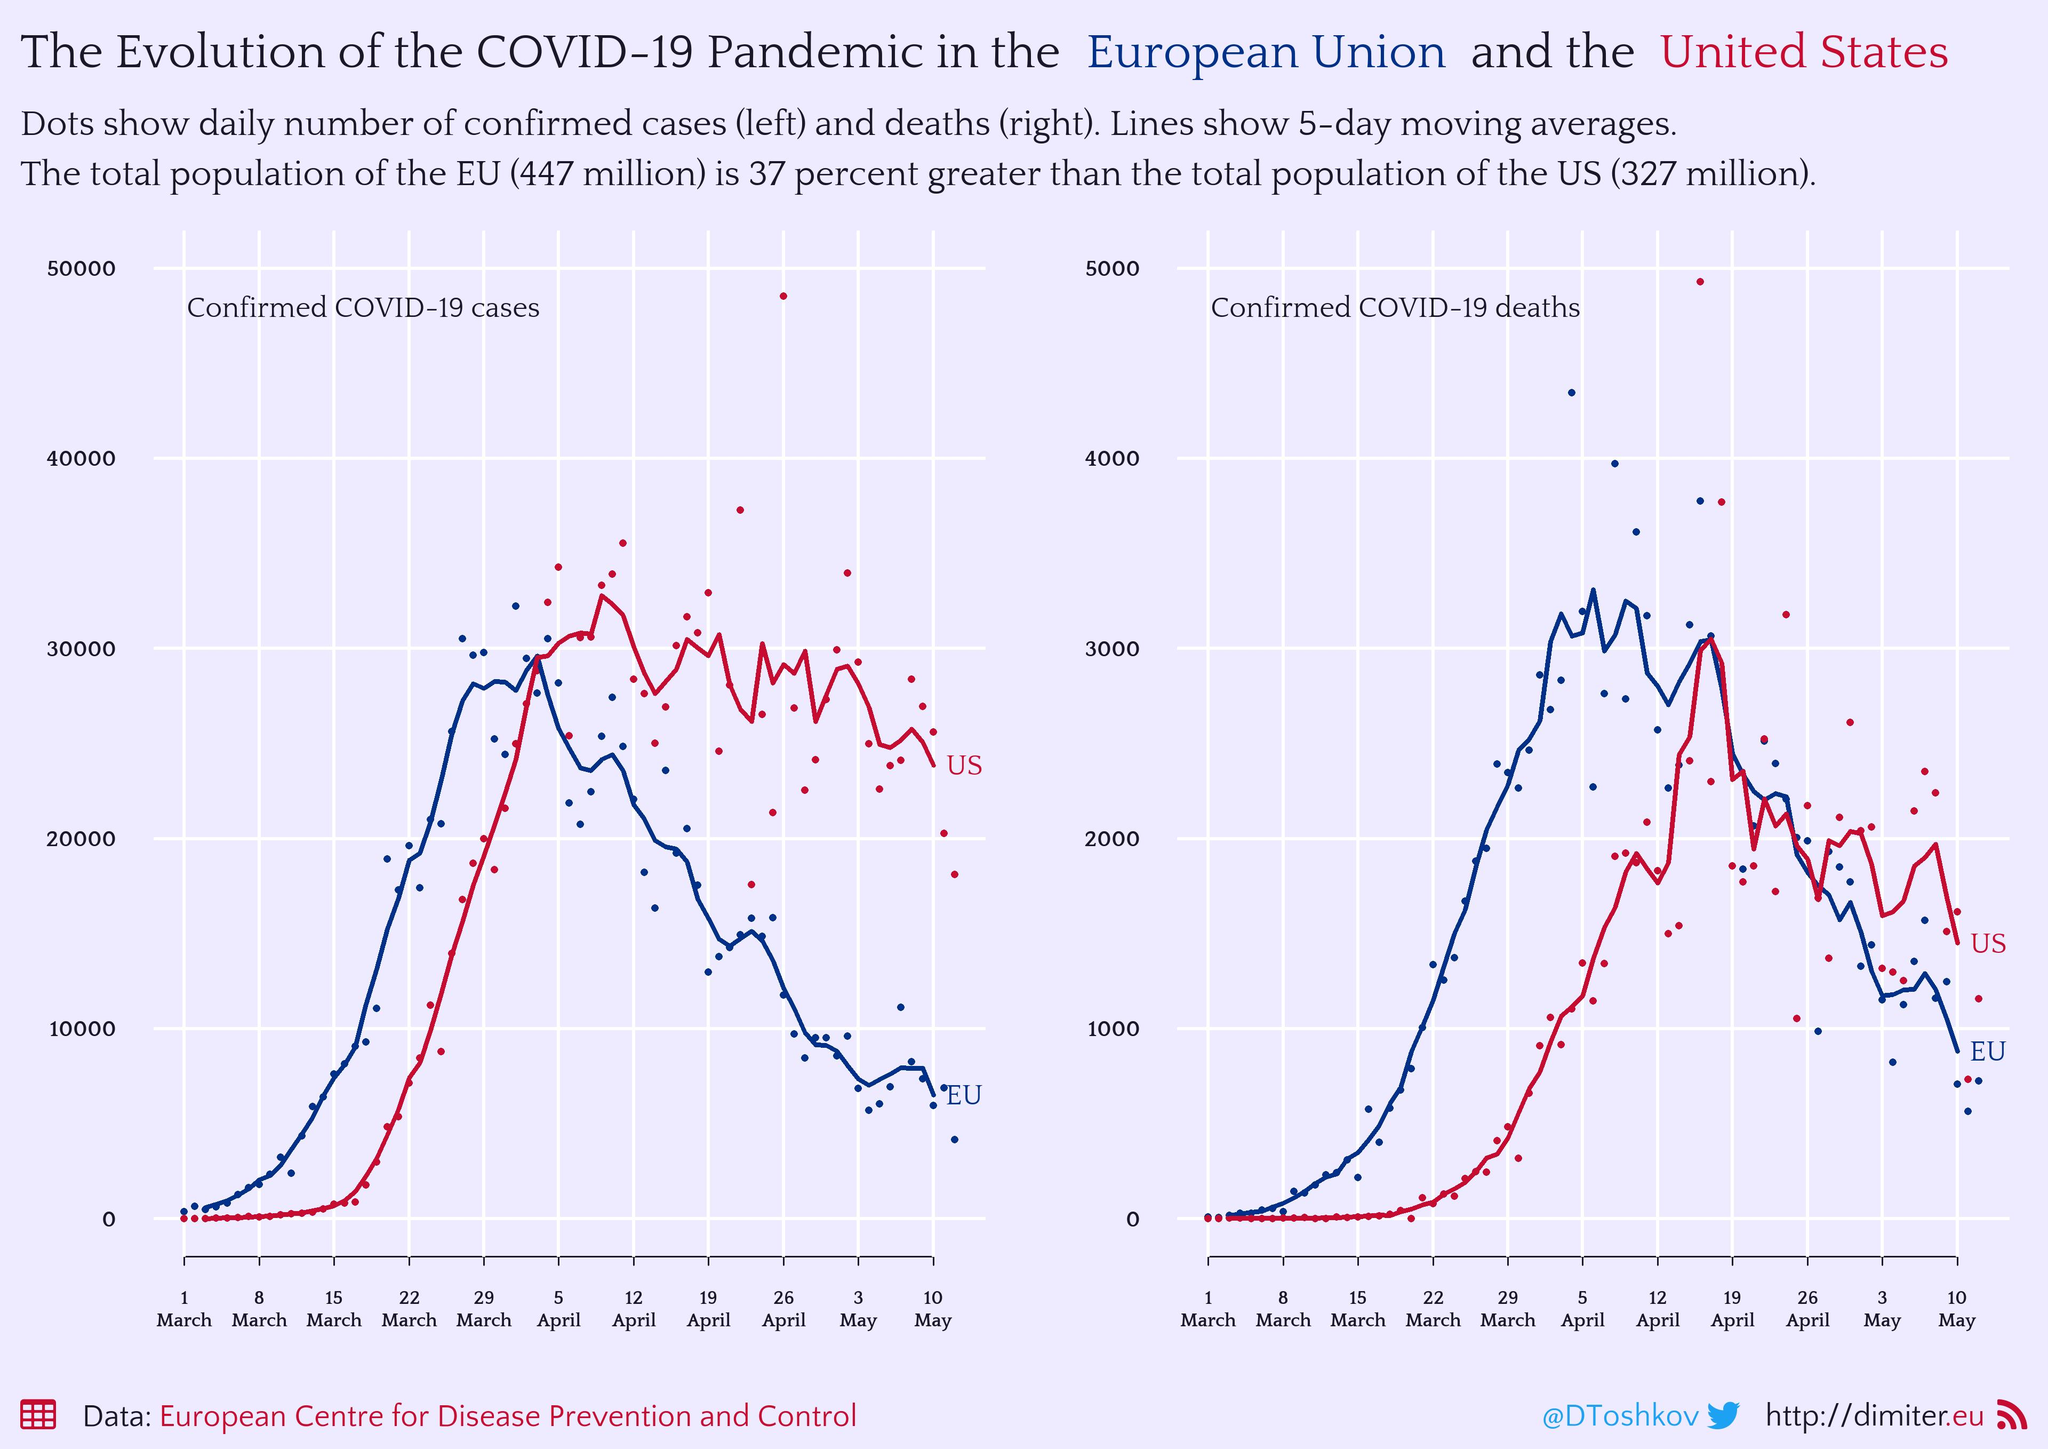List a handful of essential elements in this visual. The blue line pertains to the European Union. The highest number of deaths was reported in the month of April in the United States. The highest case was in April in the US. The highest number of deaths was reported in April in the European Union. The red line indicates that the country in question is the United States. 